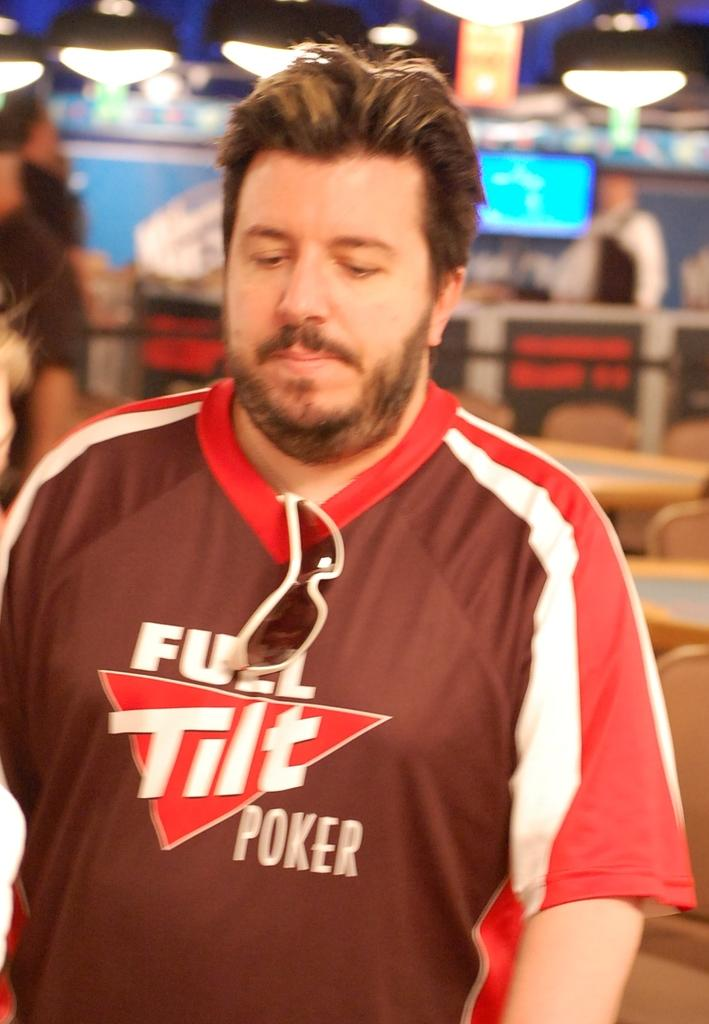<image>
Give a short and clear explanation of the subsequent image. A man is standing at a poker table with a Full Tilt Poker shirt on. 